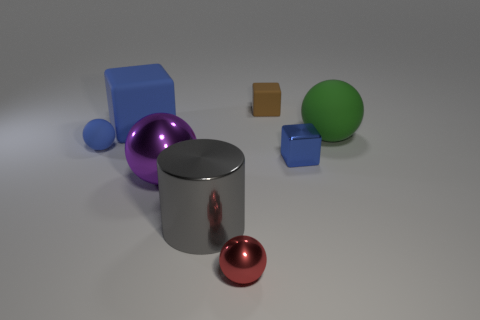How many gray shiny cylinders are in front of the tiny blue thing that is right of the tiny blue matte thing?
Ensure brevity in your answer.  1. What number of other objects are the same size as the brown matte object?
Give a very brief answer. 3. The other block that is the same color as the tiny metallic block is what size?
Ensure brevity in your answer.  Large. Is the shape of the small rubber object on the left side of the red ball the same as  the brown rubber thing?
Your answer should be very brief. No. What is the material of the blue block on the left side of the large gray metallic cylinder?
Your answer should be compact. Rubber. What is the shape of the big object that is the same color as the metallic cube?
Give a very brief answer. Cube. Are there any large green objects made of the same material as the large gray cylinder?
Provide a succinct answer. No. What is the size of the gray shiny cylinder?
Your response must be concise. Large. What number of cyan objects are blocks or tiny cubes?
Your response must be concise. 0. What number of other big green rubber things are the same shape as the big green rubber object?
Ensure brevity in your answer.  0. 